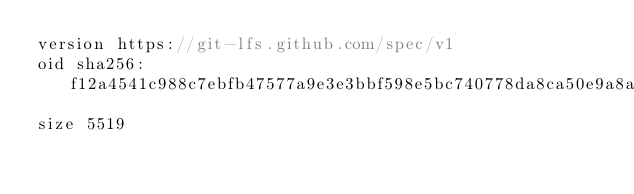<code> <loc_0><loc_0><loc_500><loc_500><_JavaScript_>version https://git-lfs.github.com/spec/v1
oid sha256:f12a4541c988c7ebfb47577a9e3e3bbf598e5bc740778da8ca50e9a8a250613a
size 5519
</code> 